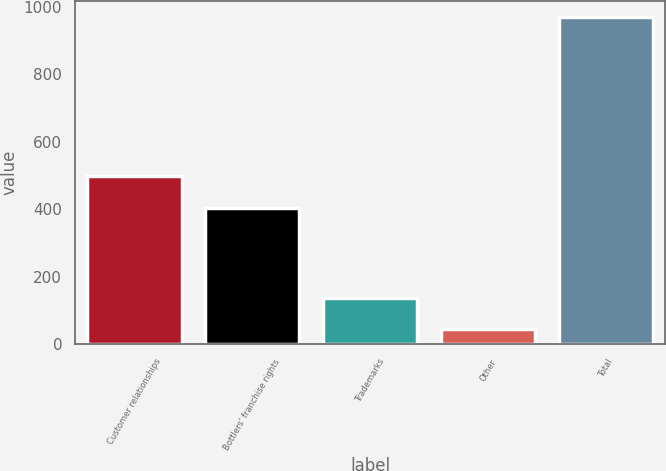<chart> <loc_0><loc_0><loc_500><loc_500><bar_chart><fcel>Customer relationships<fcel>Bottlers' franchise rights<fcel>Trademarks<fcel>Other<fcel>Total<nl><fcel>497.4<fcel>405<fcel>137.4<fcel>45<fcel>969<nl></chart> 